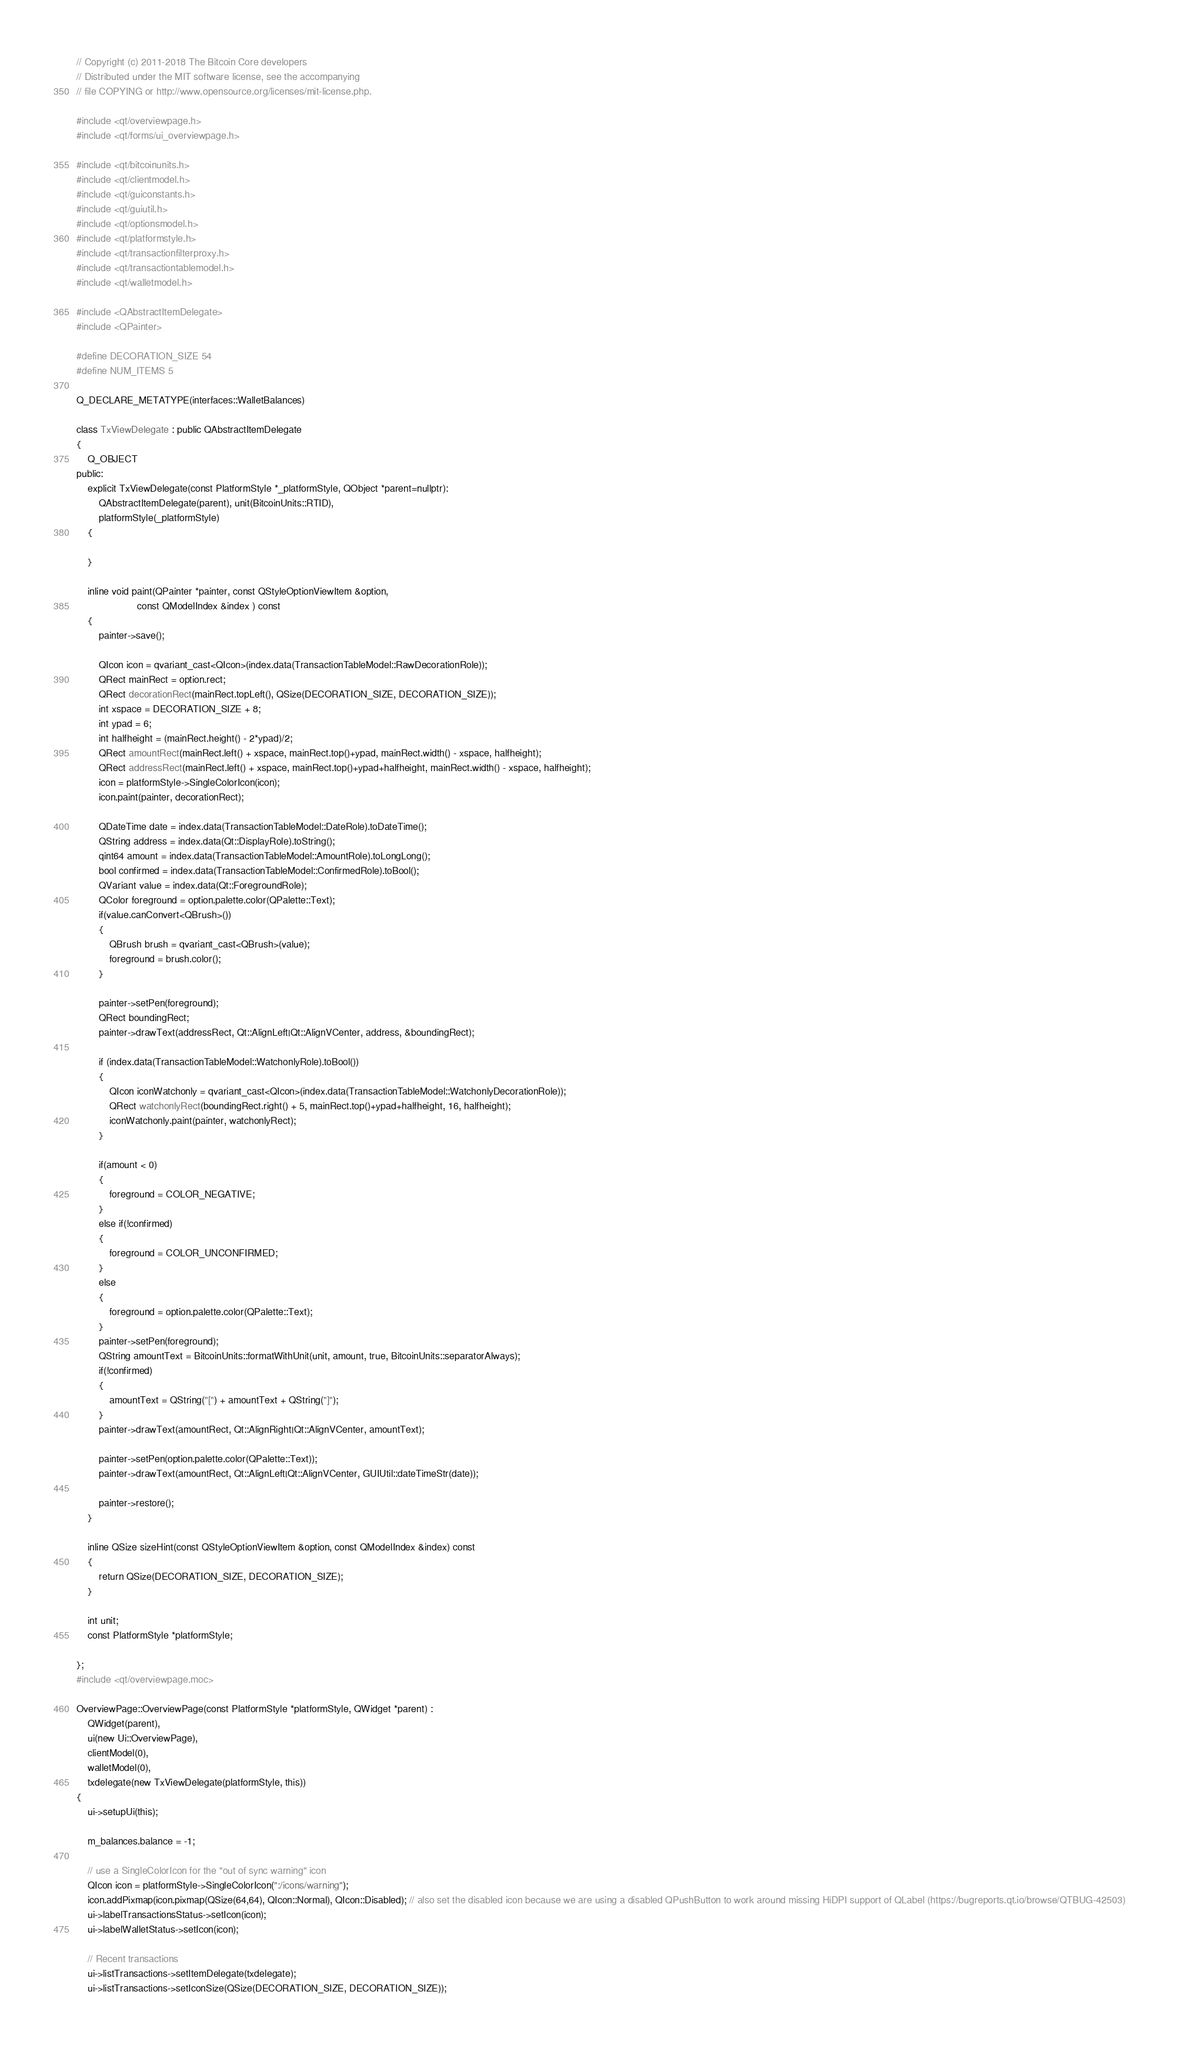<code> <loc_0><loc_0><loc_500><loc_500><_C++_>// Copyright (c) 2011-2018 The Bitcoin Core developers
// Distributed under the MIT software license, see the accompanying
// file COPYING or http://www.opensource.org/licenses/mit-license.php.

#include <qt/overviewpage.h>
#include <qt/forms/ui_overviewpage.h>

#include <qt/bitcoinunits.h>
#include <qt/clientmodel.h>
#include <qt/guiconstants.h>
#include <qt/guiutil.h>
#include <qt/optionsmodel.h>
#include <qt/platformstyle.h>
#include <qt/transactionfilterproxy.h>
#include <qt/transactiontablemodel.h>
#include <qt/walletmodel.h>

#include <QAbstractItemDelegate>
#include <QPainter>

#define DECORATION_SIZE 54
#define NUM_ITEMS 5

Q_DECLARE_METATYPE(interfaces::WalletBalances)

class TxViewDelegate : public QAbstractItemDelegate
{
    Q_OBJECT
public:
    explicit TxViewDelegate(const PlatformStyle *_platformStyle, QObject *parent=nullptr):
        QAbstractItemDelegate(parent), unit(BitcoinUnits::RTID),
        platformStyle(_platformStyle)
    {

    }

    inline void paint(QPainter *painter, const QStyleOptionViewItem &option,
                      const QModelIndex &index ) const
    {
        painter->save();

        QIcon icon = qvariant_cast<QIcon>(index.data(TransactionTableModel::RawDecorationRole));
        QRect mainRect = option.rect;
        QRect decorationRect(mainRect.topLeft(), QSize(DECORATION_SIZE, DECORATION_SIZE));
        int xspace = DECORATION_SIZE + 8;
        int ypad = 6;
        int halfheight = (mainRect.height() - 2*ypad)/2;
        QRect amountRect(mainRect.left() + xspace, mainRect.top()+ypad, mainRect.width() - xspace, halfheight);
        QRect addressRect(mainRect.left() + xspace, mainRect.top()+ypad+halfheight, mainRect.width() - xspace, halfheight);
        icon = platformStyle->SingleColorIcon(icon);
        icon.paint(painter, decorationRect);

        QDateTime date = index.data(TransactionTableModel::DateRole).toDateTime();
        QString address = index.data(Qt::DisplayRole).toString();
        qint64 amount = index.data(TransactionTableModel::AmountRole).toLongLong();
        bool confirmed = index.data(TransactionTableModel::ConfirmedRole).toBool();
        QVariant value = index.data(Qt::ForegroundRole);
        QColor foreground = option.palette.color(QPalette::Text);
        if(value.canConvert<QBrush>())
        {
            QBrush brush = qvariant_cast<QBrush>(value);
            foreground = brush.color();
        }

        painter->setPen(foreground);
        QRect boundingRect;
        painter->drawText(addressRect, Qt::AlignLeft|Qt::AlignVCenter, address, &boundingRect);

        if (index.data(TransactionTableModel::WatchonlyRole).toBool())
        {
            QIcon iconWatchonly = qvariant_cast<QIcon>(index.data(TransactionTableModel::WatchonlyDecorationRole));
            QRect watchonlyRect(boundingRect.right() + 5, mainRect.top()+ypad+halfheight, 16, halfheight);
            iconWatchonly.paint(painter, watchonlyRect);
        }

        if(amount < 0)
        {
            foreground = COLOR_NEGATIVE;
        }
        else if(!confirmed)
        {
            foreground = COLOR_UNCONFIRMED;
        }
        else
        {
            foreground = option.palette.color(QPalette::Text);
        }
        painter->setPen(foreground);
        QString amountText = BitcoinUnits::formatWithUnit(unit, amount, true, BitcoinUnits::separatorAlways);
        if(!confirmed)
        {
            amountText = QString("[") + amountText + QString("]");
        }
        painter->drawText(amountRect, Qt::AlignRight|Qt::AlignVCenter, amountText);

        painter->setPen(option.palette.color(QPalette::Text));
        painter->drawText(amountRect, Qt::AlignLeft|Qt::AlignVCenter, GUIUtil::dateTimeStr(date));

        painter->restore();
    }

    inline QSize sizeHint(const QStyleOptionViewItem &option, const QModelIndex &index) const
    {
        return QSize(DECORATION_SIZE, DECORATION_SIZE);
    }

    int unit;
    const PlatformStyle *platformStyle;

};
#include <qt/overviewpage.moc>

OverviewPage::OverviewPage(const PlatformStyle *platformStyle, QWidget *parent) :
    QWidget(parent),
    ui(new Ui::OverviewPage),
    clientModel(0),
    walletModel(0),
    txdelegate(new TxViewDelegate(platformStyle, this))
{
    ui->setupUi(this);

    m_balances.balance = -1;

    // use a SingleColorIcon for the "out of sync warning" icon
    QIcon icon = platformStyle->SingleColorIcon(":/icons/warning");
    icon.addPixmap(icon.pixmap(QSize(64,64), QIcon::Normal), QIcon::Disabled); // also set the disabled icon because we are using a disabled QPushButton to work around missing HiDPI support of QLabel (https://bugreports.qt.io/browse/QTBUG-42503)
    ui->labelTransactionsStatus->setIcon(icon);
    ui->labelWalletStatus->setIcon(icon);

    // Recent transactions
    ui->listTransactions->setItemDelegate(txdelegate);
    ui->listTransactions->setIconSize(QSize(DECORATION_SIZE, DECORATION_SIZE));</code> 